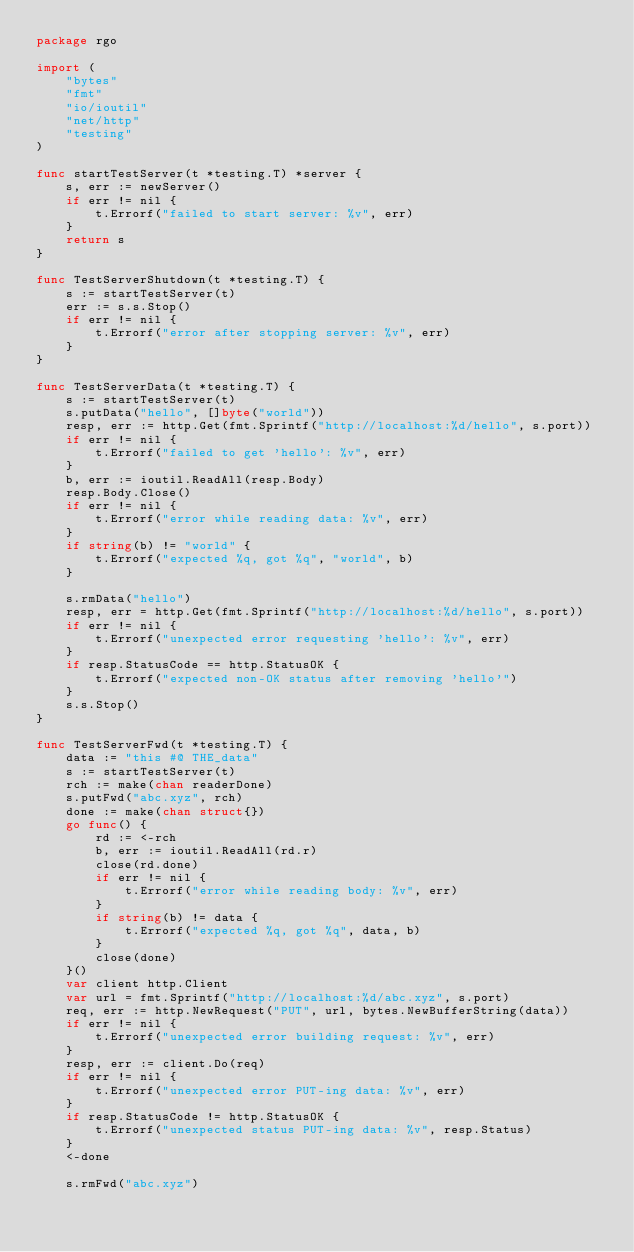Convert code to text. <code><loc_0><loc_0><loc_500><loc_500><_Go_>package rgo

import (
	"bytes"
	"fmt"
	"io/ioutil"
	"net/http"
	"testing"
)

func startTestServer(t *testing.T) *server {
	s, err := newServer()
	if err != nil {
		t.Errorf("failed to start server: %v", err)
	}
	return s
}

func TestServerShutdown(t *testing.T) {
	s := startTestServer(t)
	err := s.s.Stop()
	if err != nil {
		t.Errorf("error after stopping server: %v", err)
	}
}

func TestServerData(t *testing.T) {
	s := startTestServer(t)
	s.putData("hello", []byte("world"))
	resp, err := http.Get(fmt.Sprintf("http://localhost:%d/hello", s.port))
	if err != nil {
		t.Errorf("failed to get 'hello': %v", err)
	}
	b, err := ioutil.ReadAll(resp.Body)
	resp.Body.Close()
	if err != nil {
		t.Errorf("error while reading data: %v", err)
	}
	if string(b) != "world" {
		t.Errorf("expected %q, got %q", "world", b)
	}

	s.rmData("hello")
	resp, err = http.Get(fmt.Sprintf("http://localhost:%d/hello", s.port))
	if err != nil {
		t.Errorf("unexpected error requesting 'hello': %v", err)
	}
	if resp.StatusCode == http.StatusOK {
		t.Errorf("expected non-OK status after removing 'hello'")
	}
	s.s.Stop()
}

func TestServerFwd(t *testing.T) {
	data := "this #@ THE_data"
	s := startTestServer(t)
	rch := make(chan readerDone)
	s.putFwd("abc.xyz", rch)
	done := make(chan struct{})
	go func() {
		rd := <-rch
		b, err := ioutil.ReadAll(rd.r)
		close(rd.done)
		if err != nil {
			t.Errorf("error while reading body: %v", err)
		}
		if string(b) != data {
			t.Errorf("expected %q, got %q", data, b)
		}
		close(done)
	}()
	var client http.Client
	var url = fmt.Sprintf("http://localhost:%d/abc.xyz", s.port)
	req, err := http.NewRequest("PUT", url, bytes.NewBufferString(data))
	if err != nil {
		t.Errorf("unexpected error building request: %v", err)
	}
	resp, err := client.Do(req)
	if err != nil {
		t.Errorf("unexpected error PUT-ing data: %v", err)
	}
	if resp.StatusCode != http.StatusOK {
		t.Errorf("unexpected status PUT-ing data: %v", resp.Status)
	}
	<-done

	s.rmFwd("abc.xyz")</code> 